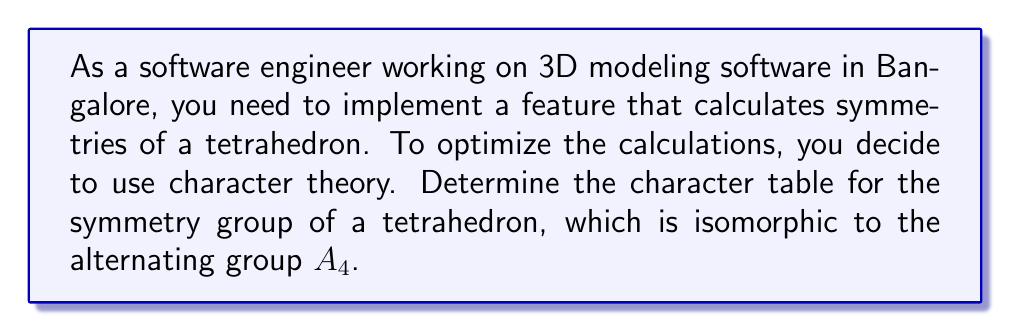Help me with this question. Let's approach this step-by-step:

1) First, we need to identify the conjugacy classes of $A_4$:
   - Class 1: $\{e\}$ (identity)
   - Class 2: $\{(12)(34), (13)(24), (14)(23)\}$ (3 elements)
   - Class 3: $\{(123), (132), (124), (142), (134), (143), (234), (243)\}$ (8 elements)

2) The number of irreducible representations is equal to the number of conjugacy classes, so we have 3 irreducible representations.

3) We know that the sum of the squares of the dimensions of irreducible representations must equal the order of the group:

   $d_1^2 + d_2^2 + d_3^2 = |A_4| = 12$

4) The only solution for this is $1^2 + 1^2 + 2^2 = 12$, so we have two 1-dimensional representations and one 2-dimensional representation.

5) The trivial representation $\chi_1$ has character 1 for all classes.

6) For the second 1-dimensional representation $\chi_2$, we can use the fact that $A_4$ is the group of even permutations. All 3-cycles are even, but 2-2 cycles are odd in $S_4$ but even in $A_4$. So, $\chi_2$ will be 1 for identity and 3-cycles, but -1 for 2-2 cycles.

7) For the 2-dimensional representation $\chi_3$, we can use the orthogonality relations and the fact that the sum of squares of characters in each column must equal $|C_g|$ (size of the conjugacy class):

   For Class 2: $1^2 + (-1)^2 + x^2 = 3$, so $x = -1$
   For Class 3: $1^2 + 1^2 + y^2 = 8$, so $y = 0$

8) We can now construct the character table:

   $$\begin{array}{c|ccc}
      & e & (12)(34) & (123) \\
   \hline
   \chi_1 & 1 & 1 & 1 \\
   \chi_2 & 1 & -1 & 1 \\
   \chi_3 & 2 & 0 & -1
   \end{array}$$
Answer: $$\begin{array}{c|ccc}
   & e & (12)(34) & (123) \\
\hline
\chi_1 & 1 & 1 & 1 \\
\chi_2 & 1 & -1 & 1 \\
\chi_3 & 2 & 0 & -1
\end{array}$$ 